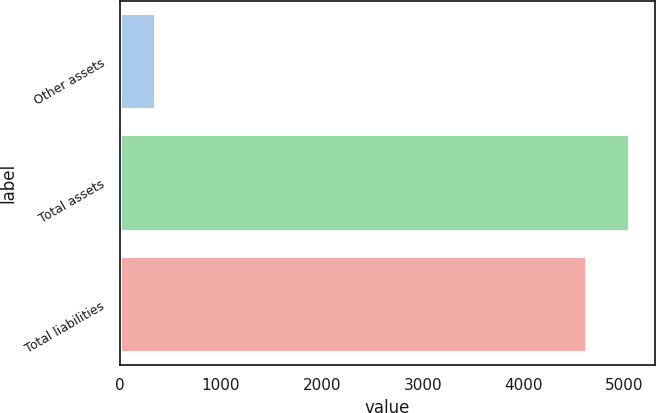Convert chart. <chart><loc_0><loc_0><loc_500><loc_500><bar_chart><fcel>Other assets<fcel>Total assets<fcel>Total liabilities<nl><fcel>360<fcel>5053.2<fcel>4626<nl></chart> 